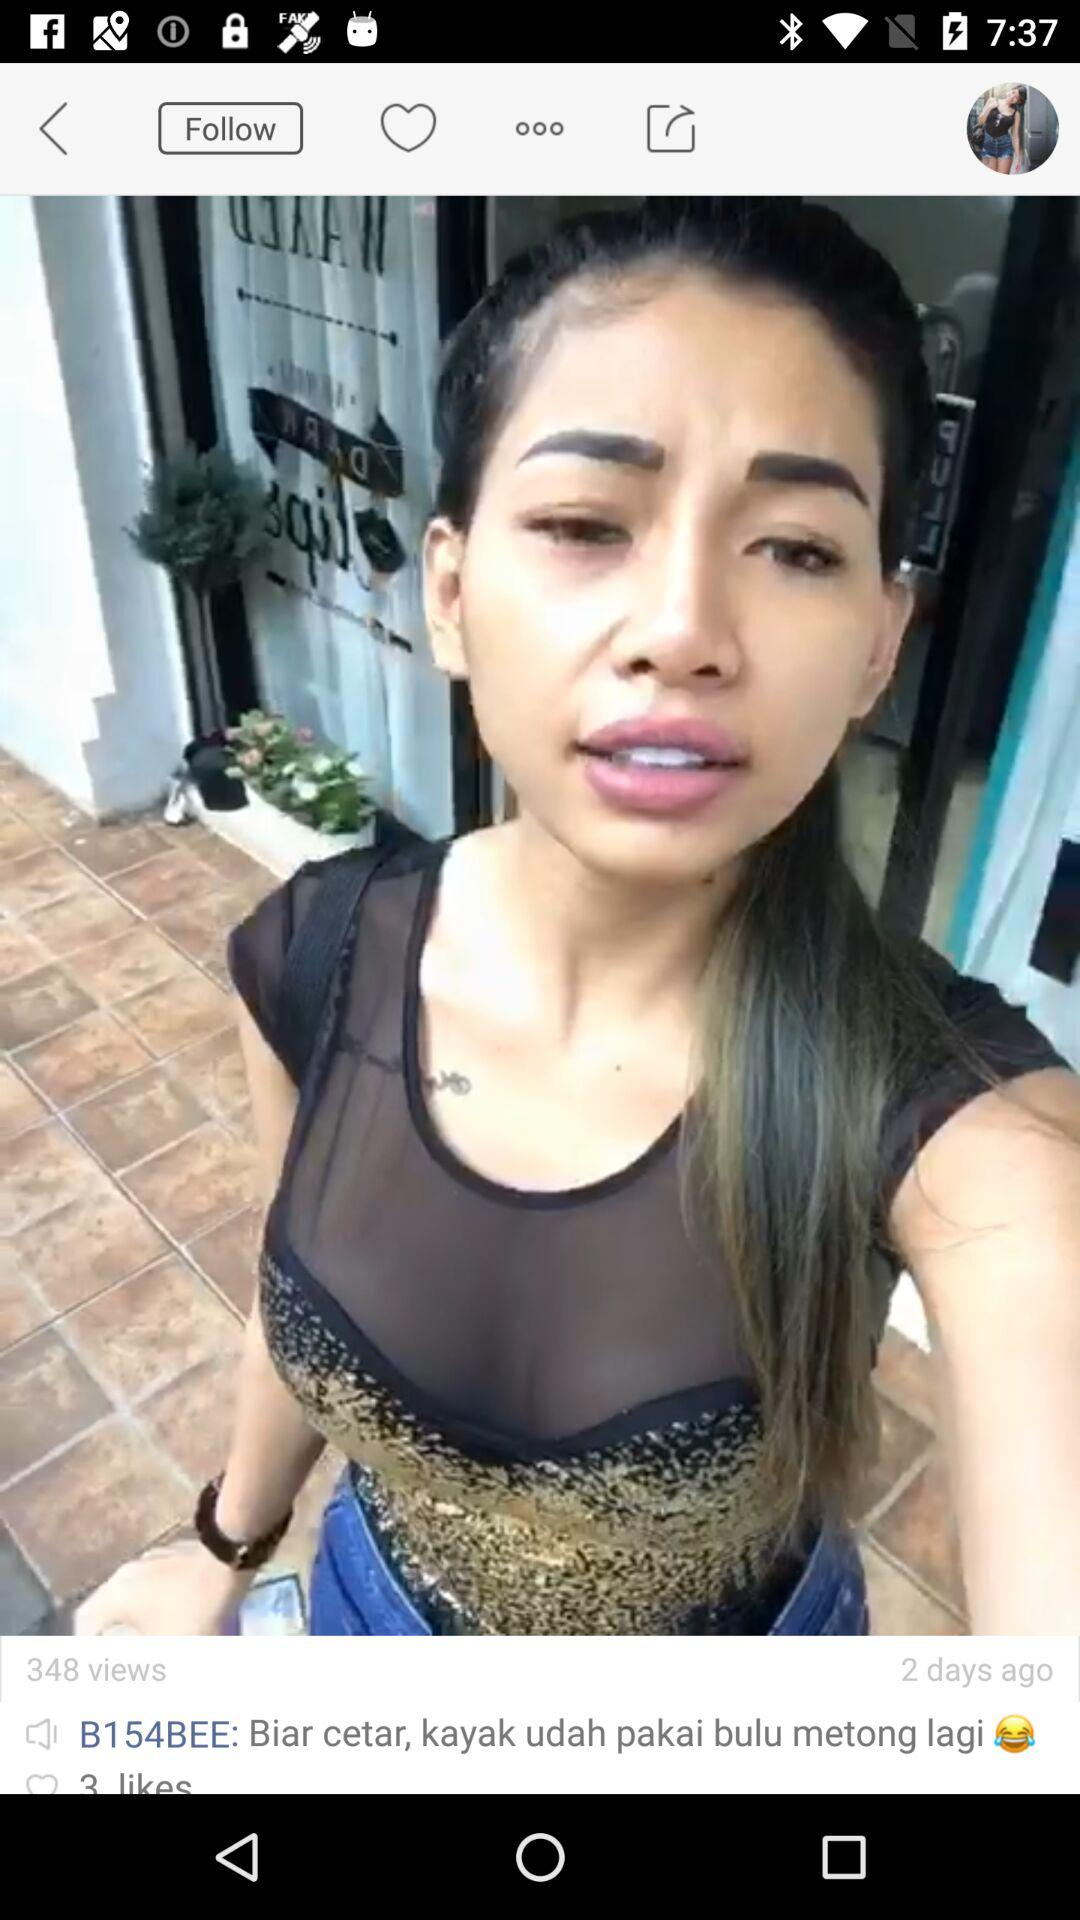How many likes does the post have?
Answer the question using a single word or phrase. 3 